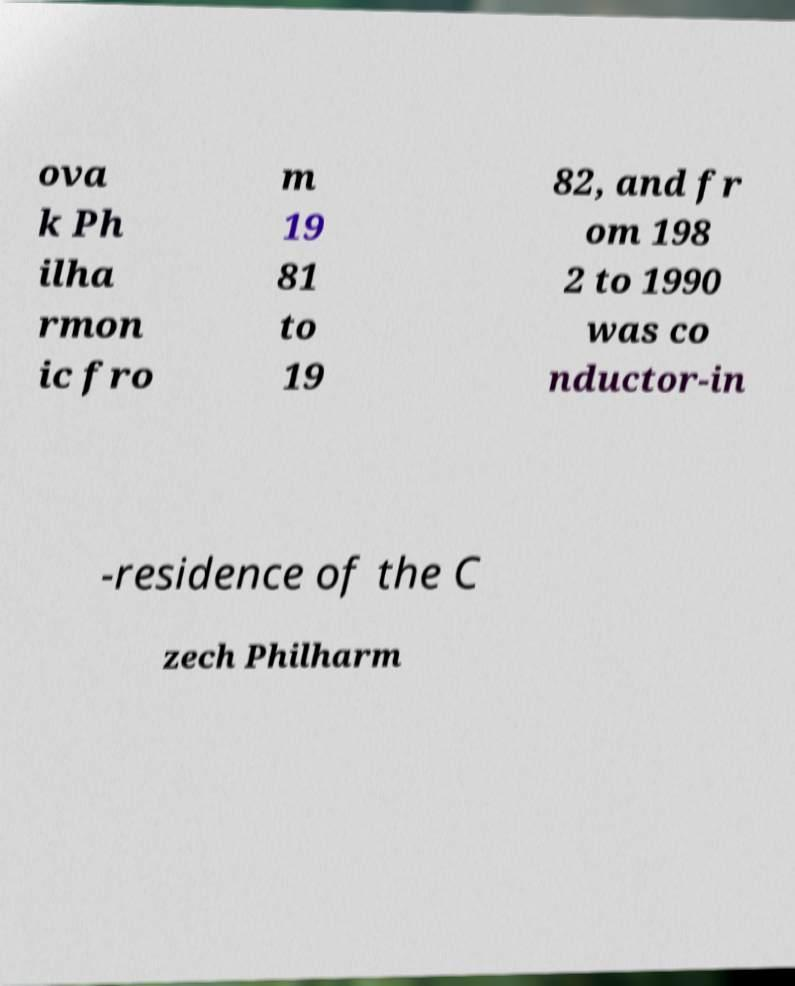Could you extract and type out the text from this image? ova k Ph ilha rmon ic fro m 19 81 to 19 82, and fr om 198 2 to 1990 was co nductor-in -residence of the C zech Philharm 